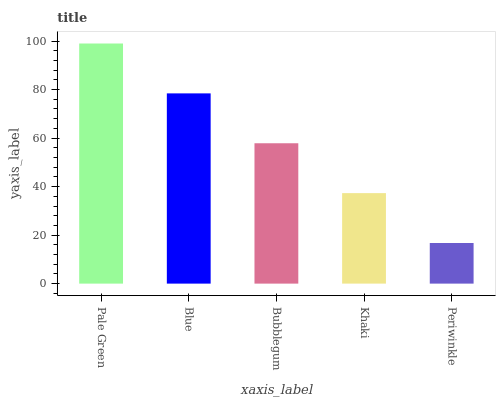Is Periwinkle the minimum?
Answer yes or no. Yes. Is Pale Green the maximum?
Answer yes or no. Yes. Is Blue the minimum?
Answer yes or no. No. Is Blue the maximum?
Answer yes or no. No. Is Pale Green greater than Blue?
Answer yes or no. Yes. Is Blue less than Pale Green?
Answer yes or no. Yes. Is Blue greater than Pale Green?
Answer yes or no. No. Is Pale Green less than Blue?
Answer yes or no. No. Is Bubblegum the high median?
Answer yes or no. Yes. Is Bubblegum the low median?
Answer yes or no. Yes. Is Khaki the high median?
Answer yes or no. No. Is Khaki the low median?
Answer yes or no. No. 